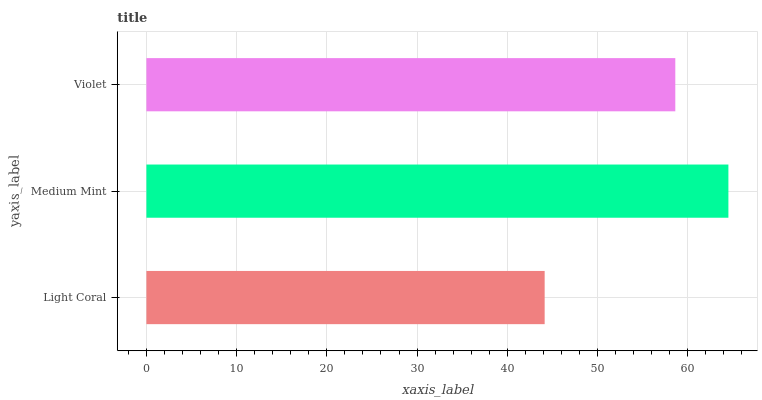Is Light Coral the minimum?
Answer yes or no. Yes. Is Medium Mint the maximum?
Answer yes or no. Yes. Is Violet the minimum?
Answer yes or no. No. Is Violet the maximum?
Answer yes or no. No. Is Medium Mint greater than Violet?
Answer yes or no. Yes. Is Violet less than Medium Mint?
Answer yes or no. Yes. Is Violet greater than Medium Mint?
Answer yes or no. No. Is Medium Mint less than Violet?
Answer yes or no. No. Is Violet the high median?
Answer yes or no. Yes. Is Violet the low median?
Answer yes or no. Yes. Is Light Coral the high median?
Answer yes or no. No. Is Light Coral the low median?
Answer yes or no. No. 